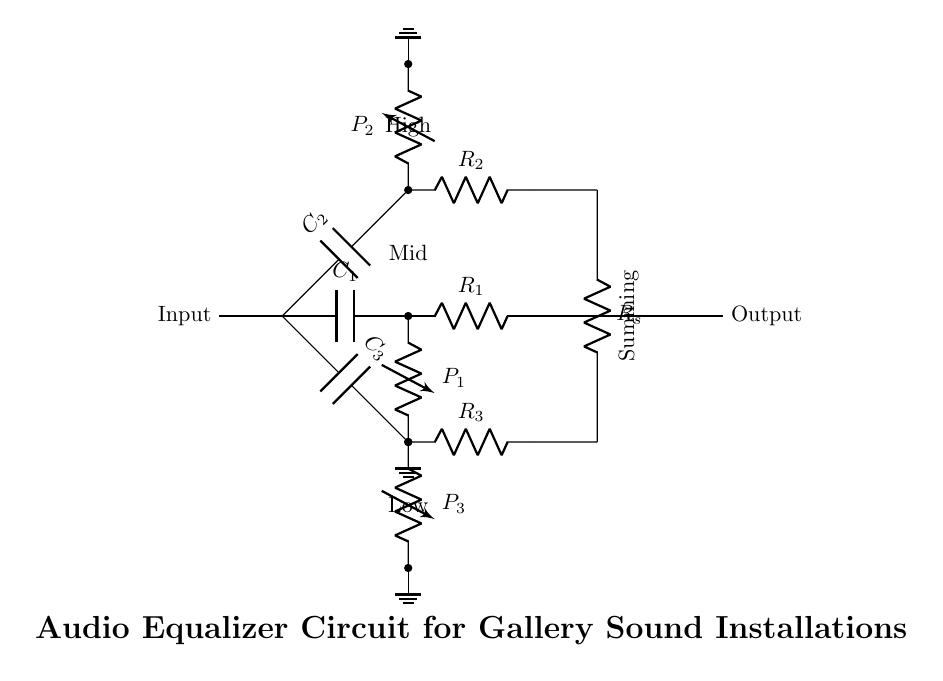What is the function of the capacitors in this circuit? The capacitors in the circuit serve as frequency-selective components that allow certain frequency ranges to pass while blocking others. Each capacitor is part of its respective branch (low, mid, or high frequency), thereby enabling the equalization of audio signals across different frequencies.
Answer: Frequency-selective What type of resistors are used in the audio equalizer circuit? The resistors in the circuit are standard resistors used to control current and provide voltage division across the branches of the circuit. They ensure that the components interact appropriately, affecting the overall response of the equalizer.
Answer: Standard How many potentiometers are present in this circuit? There are three potentiometers in the circuit, each controlling one of the frequency branches (low, mid, high), allowing for the adjustment of audio levels at those frequencies.
Answer: Three What is the purpose of the summing resistor in this circuit? The summing resistor collects the outputs from the three branches and combines them into a single output signal. It plays a crucial role in determining the overall output level of the equalized audio signal by ensuring proper mixing of the signals from each frequency branch.
Answer: Combine signals Which component measures resistance in the circuit? The resistors in the circuit measure resistance, with each resistor functioning to limit the current and set the desired interaction among the various components. They are critical for maintaining the desired frequencies and overall audio characteristics.
Answer: Resistors 